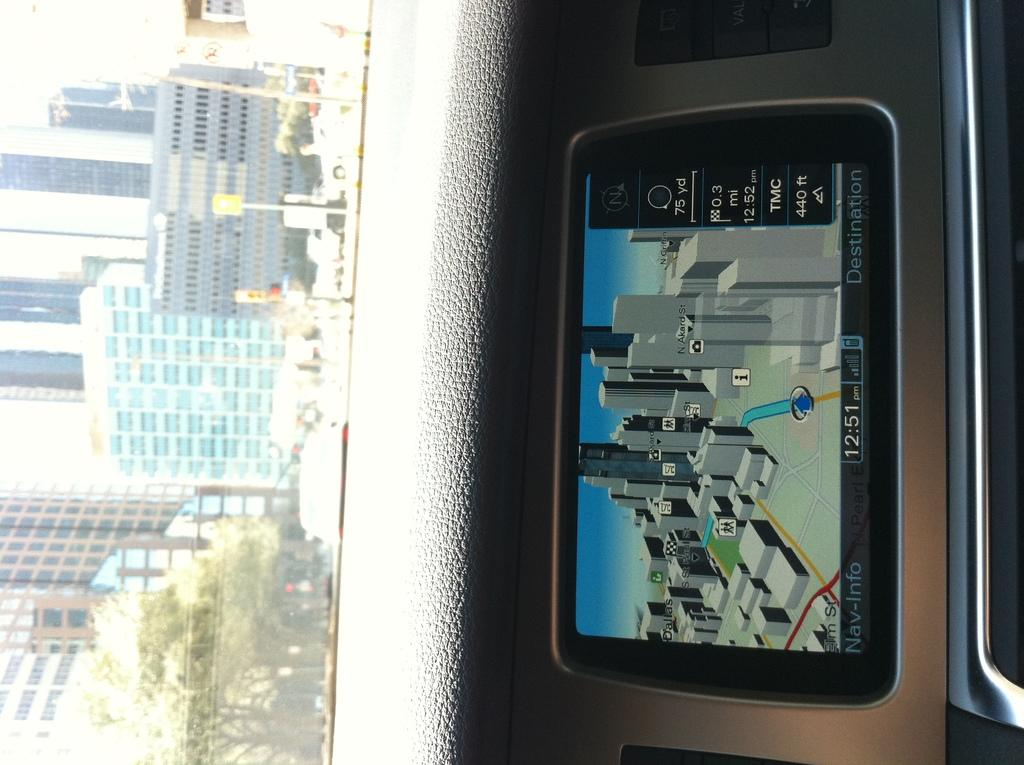<image>
Write a terse but informative summary of the picture. An in car Navigation system shows the destination is 0.3 miles away. 